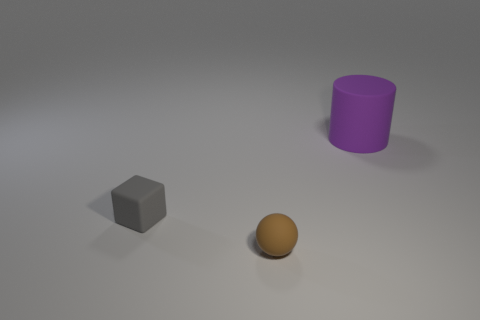Add 3 small balls. How many objects exist? 6 Subtract all cubes. How many objects are left? 2 Subtract 0 brown cubes. How many objects are left? 3 Subtract all large purple things. Subtract all small brown balls. How many objects are left? 1 Add 3 cubes. How many cubes are left? 4 Add 3 rubber cylinders. How many rubber cylinders exist? 4 